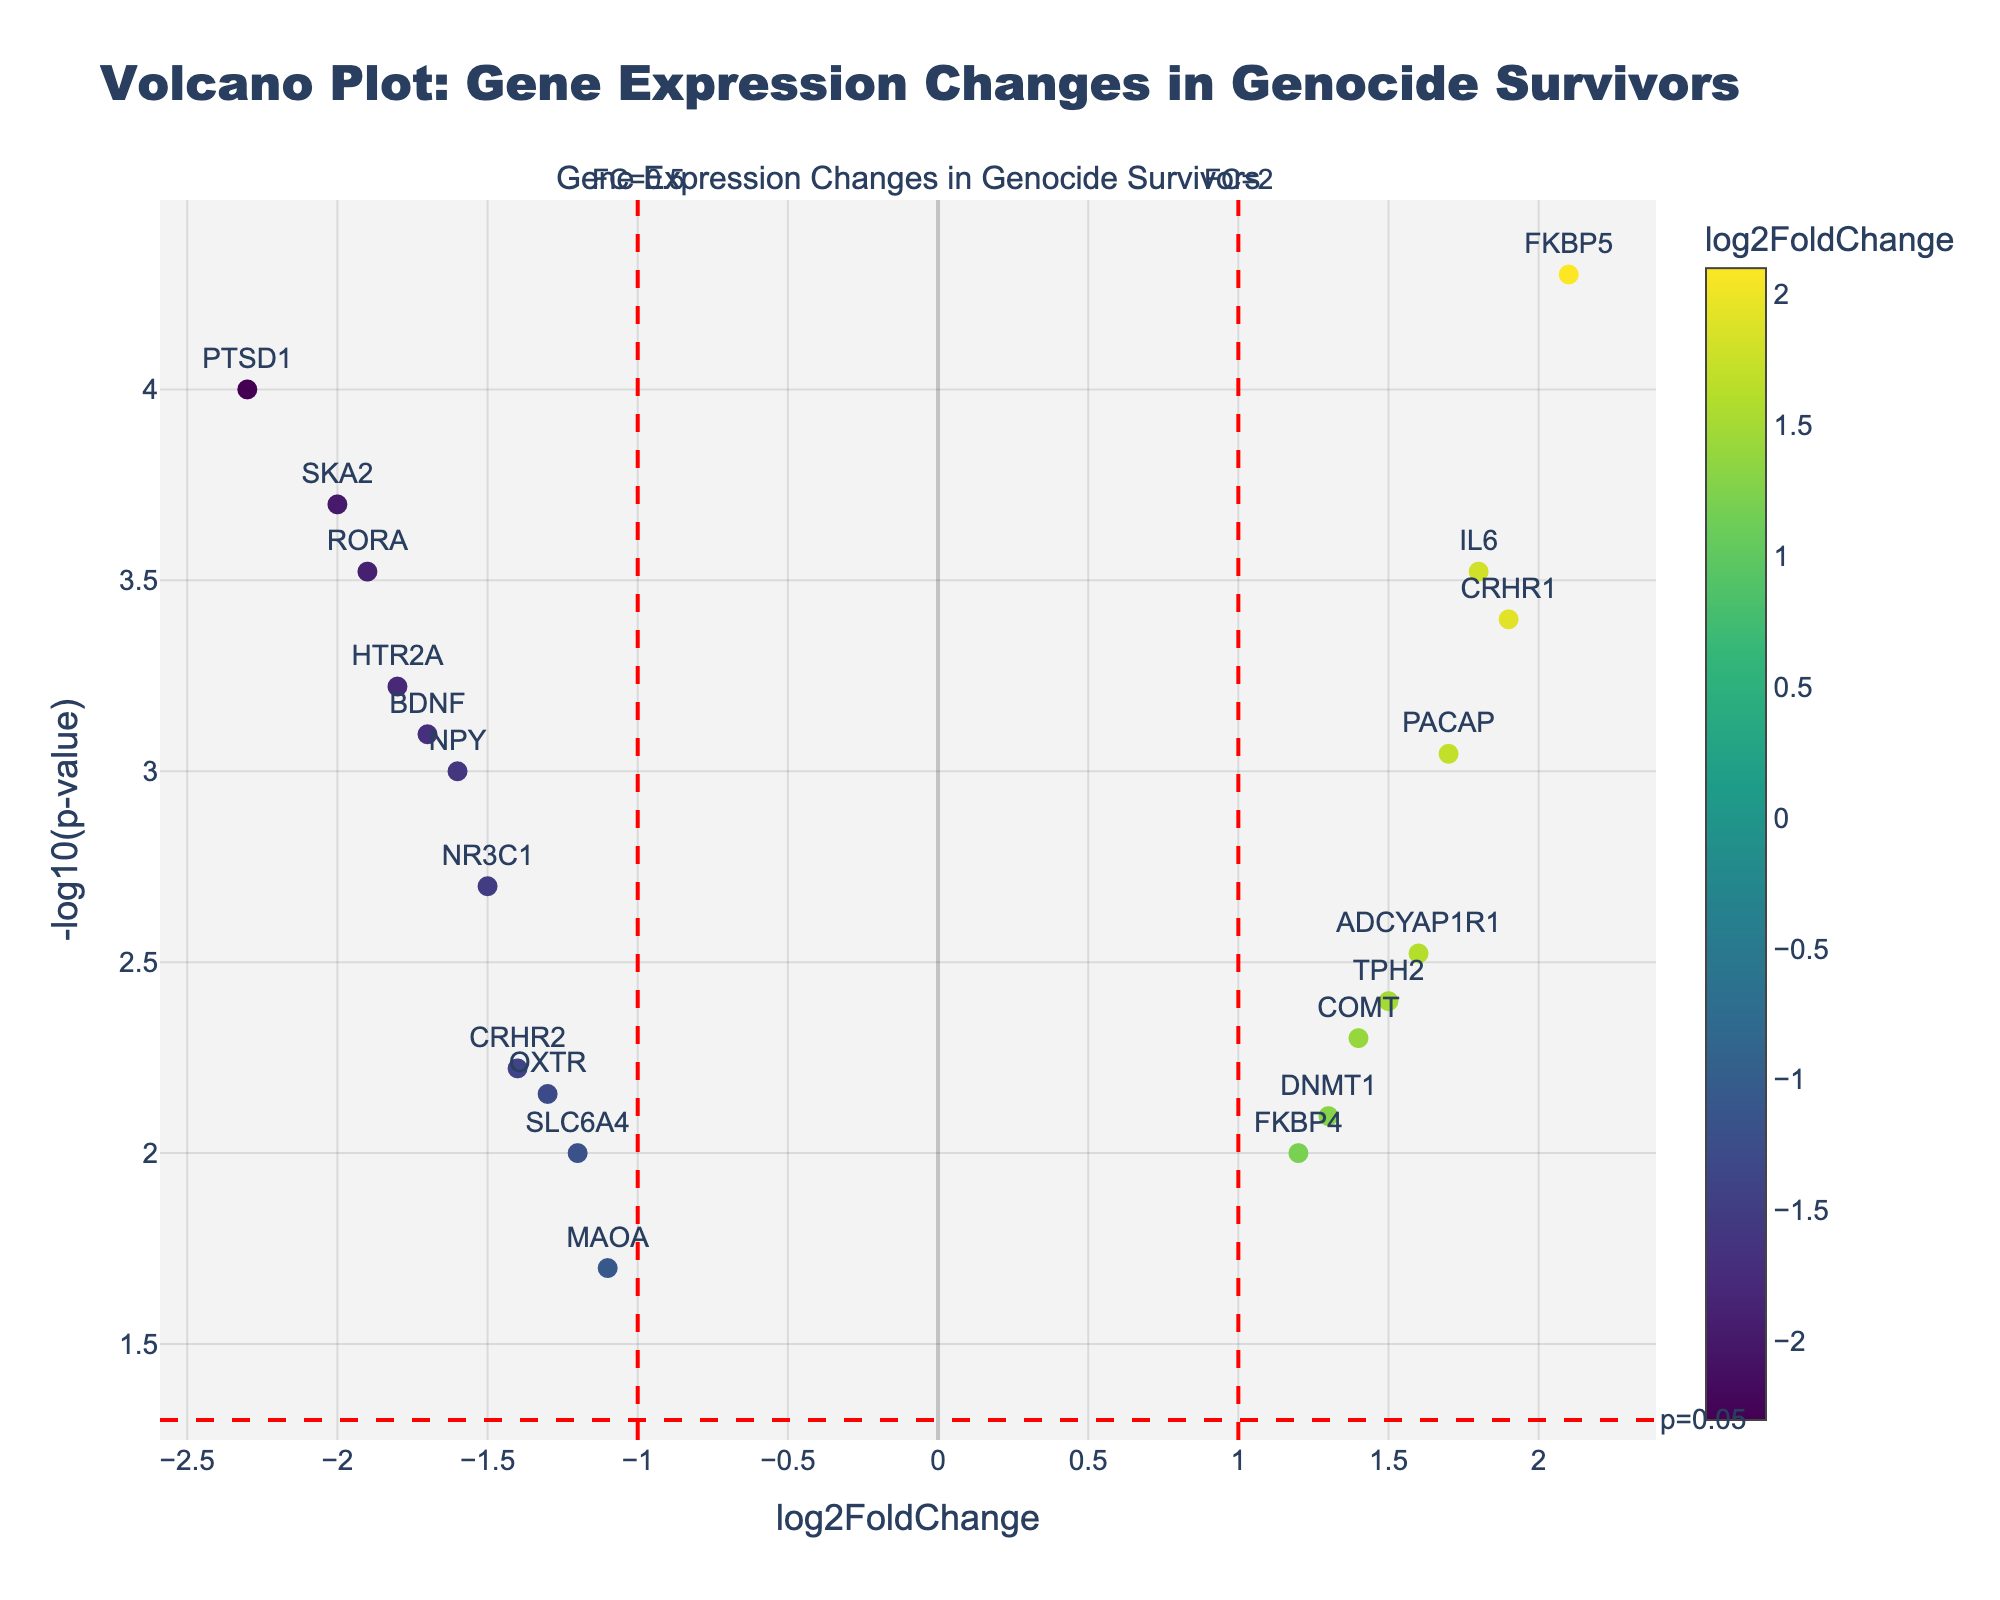What is the title of the plot? Look at the top of the figure where the title is displayed. It says "Volcano Plot: Gene Expression Changes in Genocide Survivors".
Answer: Volcano Plot: Gene Expression Changes in Genocide Survivors How many genes have a significant p-value less than 0.05? Refer to the number of points above the horizontal red line (y = -log10(0.05)) which indicates the threshold for a p-value of 0.05.
Answer: 19 Which gene has the highest log2FoldChange? Identify the data point farthest to the right on the x-axis. Hover over the points for detailed information if necessary.
Answer: FKBP5 Which gene has the lowest log2FoldChange? Identify the data point farthest to the left on the x-axis. Hover over the points for detailed information if necessary.
Answer: PTSD1 What is the -log10(p-value) for the gene IL6? Find the point labeled "IL6" and check its y-coordinate. The figure shows -log10(p-value) on the y-axis; thus, the y-coordinate corresponds to -log10(p-value).
Answer: 3.52 How many genes have a log2FoldChange greater than 1 and a -log10(p-value) greater than 2? Count the number of data points to the right of the vertical red line at x = 1 and above the horizontal red line at y = 2.
Answer: 8 Which gene is closer in log2FoldChange to OXTR, FKBP4 or IL6? Compare the x-coordinates of the genes OXTR, FKBP4, and IL6. The one closest in value to OXTR's log2FoldChange is the answer.
Answer: FKBP4 What is the log2FoldChange range of the genes on the plot? Identify the points with the maximum and minimum x-values (log2FoldChange). The range is the difference between these values.
Answer: 4.4 (2.1 - (-2.3)) Are there more genes upregulated (positive log2FoldChange) or downregulated (negative log2FoldChange)? Count the number of data points on the right side (positive x-axis) and on the left side (negative x-axis).
Answer: Downregulated Which gene has the highest significance (-log10(p-value)) among those with negative log2FoldChange? Identify the data point with the highest y-coordinate on the left side of the plot (negative x-axis).
Answer: PTSD1 